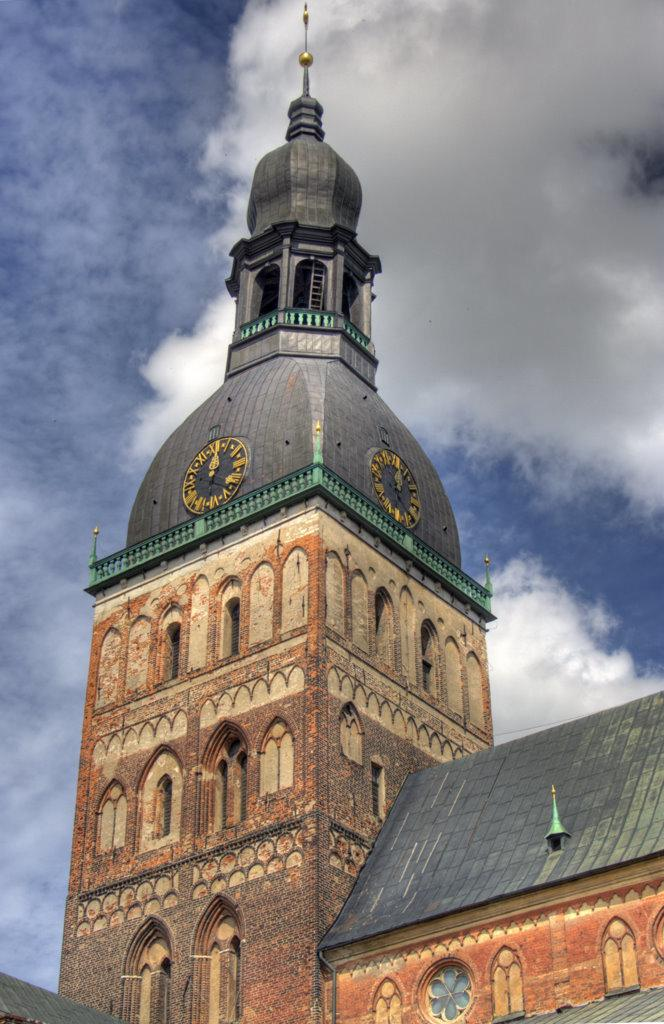What is the main structure in the middle of the image? There is a brown color clock tower in the middle of the image. What can be seen on top of the clock tower? The clock tower has a black dome with a golden rod on top. How would you describe the color of the sky in the image? The sky is blue in the image. Are there any additional features in the sky? Yes, white clouds are visible in the sky. Can you see any fangs on the horse in the image? There is no horse present in the image, and therefore no fangs can be observed. What type of truck is parked near the clock tower in the image? There is no truck present in the image; it only features a clock tower and the sky. 